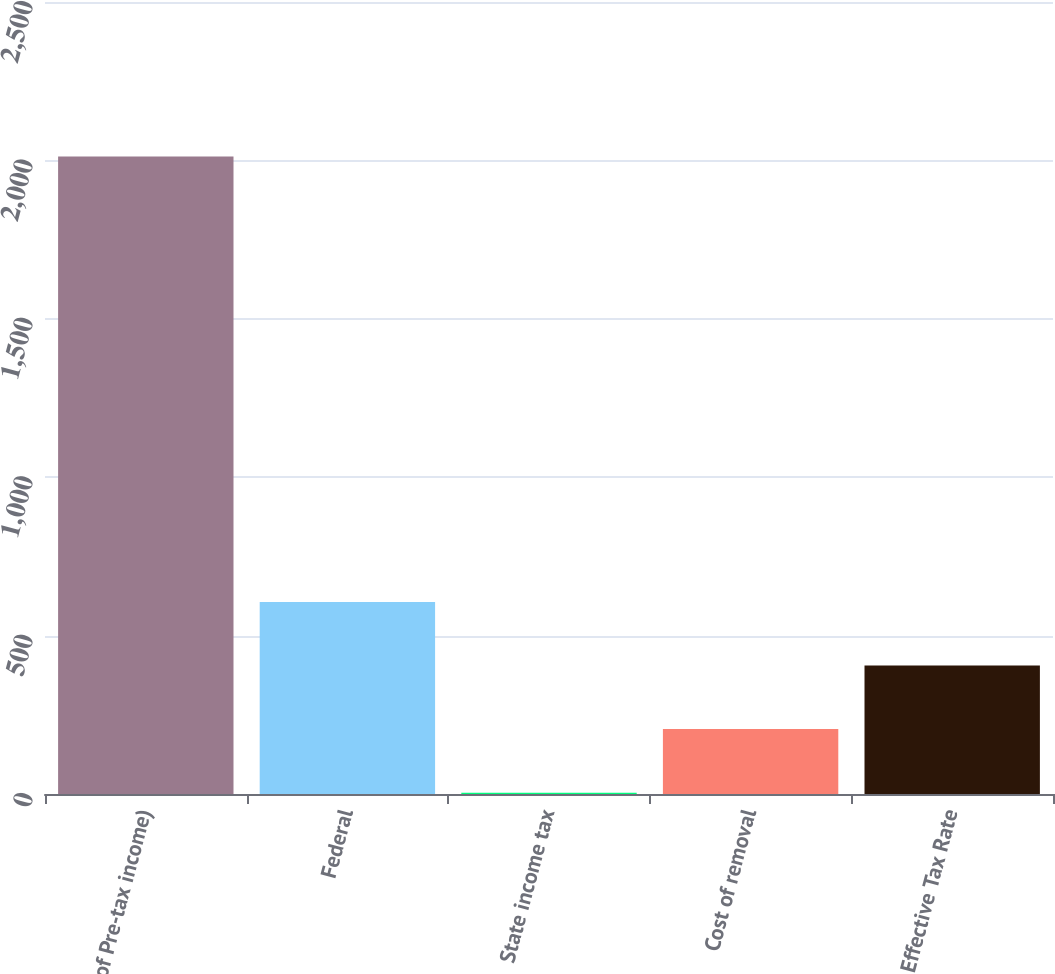Convert chart. <chart><loc_0><loc_0><loc_500><loc_500><bar_chart><fcel>( of Pre-tax income)<fcel>Federal<fcel>State income tax<fcel>Cost of removal<fcel>Effective Tax Rate<nl><fcel>2012<fcel>606.4<fcel>4<fcel>204.8<fcel>405.6<nl></chart> 